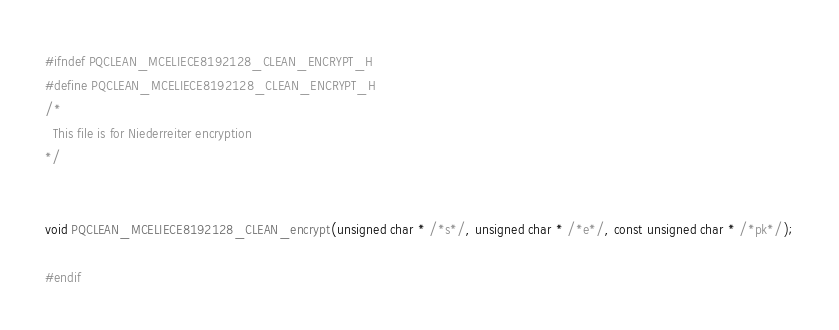<code> <loc_0><loc_0><loc_500><loc_500><_C_>#ifndef PQCLEAN_MCELIECE8192128_CLEAN_ENCRYPT_H
#define PQCLEAN_MCELIECE8192128_CLEAN_ENCRYPT_H
/*
  This file is for Niederreiter encryption
*/


void PQCLEAN_MCELIECE8192128_CLEAN_encrypt(unsigned char * /*s*/, unsigned char * /*e*/, const unsigned char * /*pk*/);

#endif

</code> 